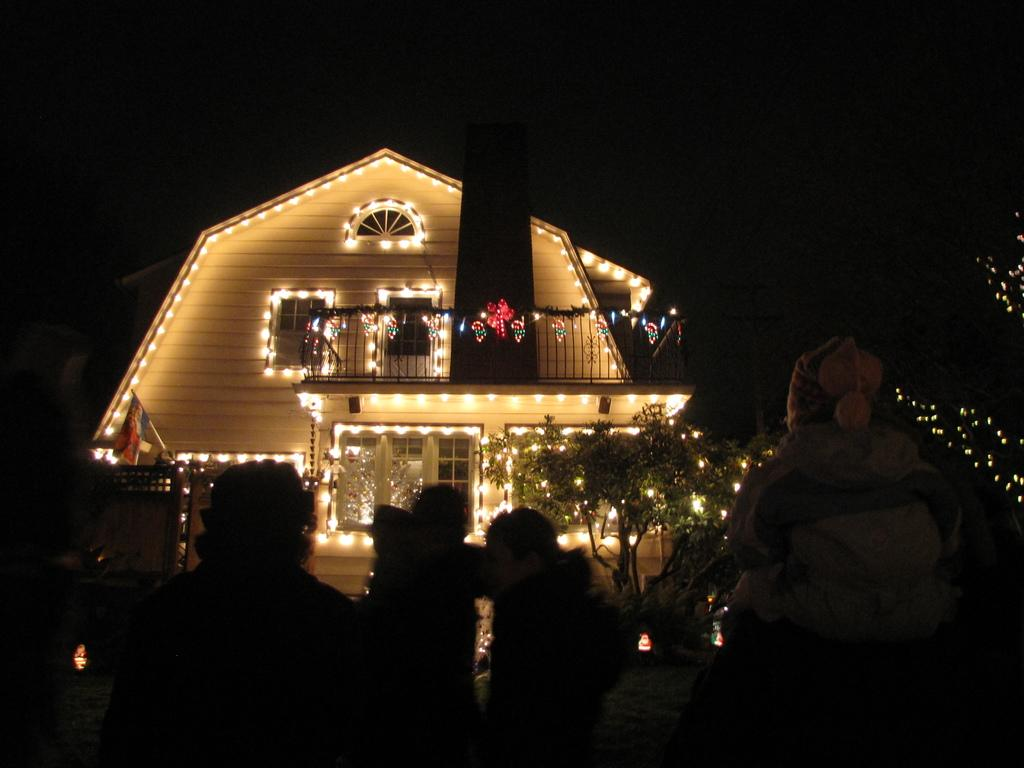What is the main subject of the image? The main subject of the image is a building. How is the building decorated? The building is decorated with lights. Are there any people present in the image? Yes, there are people standing in front of the building. What can be observed about the background of the image? The background of the image is dark. What type of trousers can be seen hanging on the shelf in the image? There is no shelf or trousers present in the image; it features a building decorated with lights and people standing in front of it. 